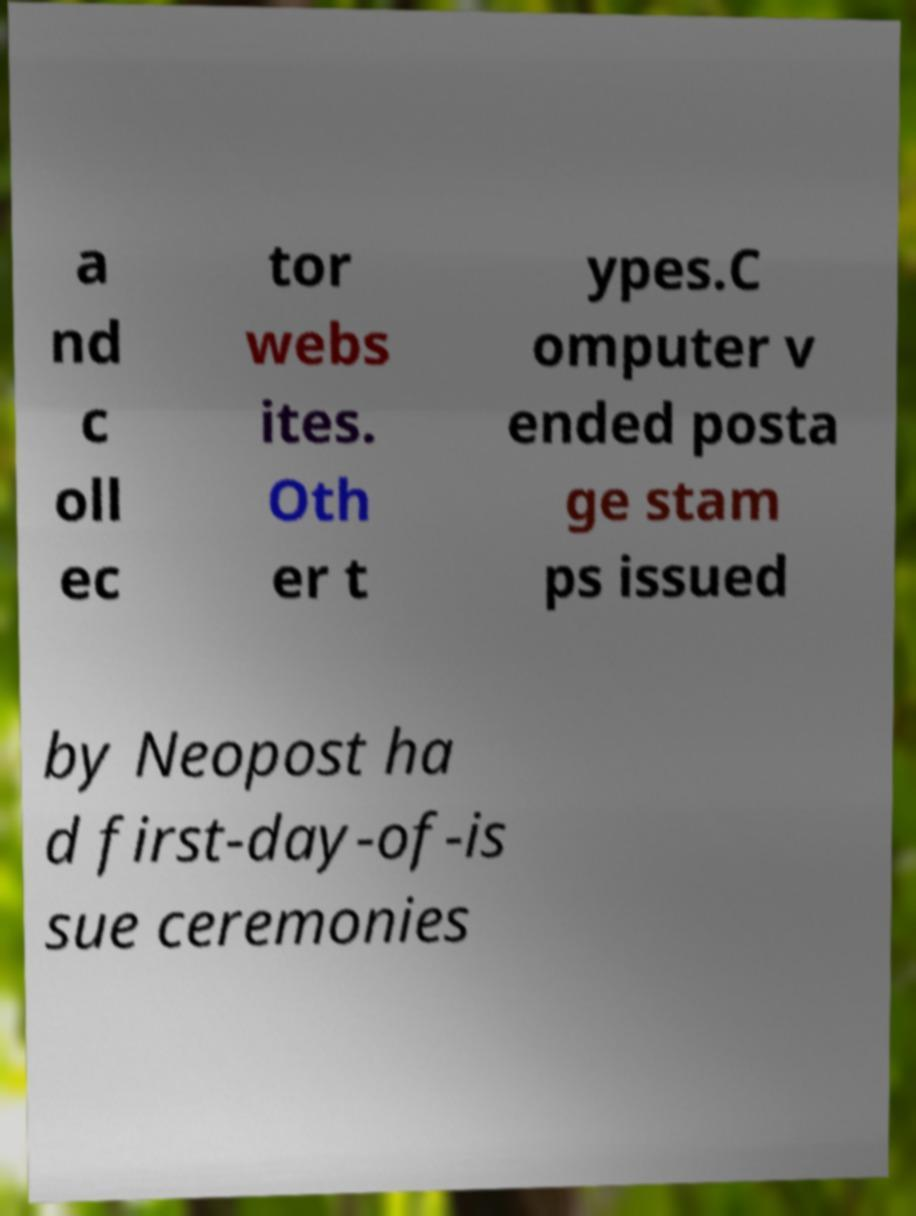What messages or text are displayed in this image? I need them in a readable, typed format. a nd c oll ec tor webs ites. Oth er t ypes.C omputer v ended posta ge stam ps issued by Neopost ha d first-day-of-is sue ceremonies 